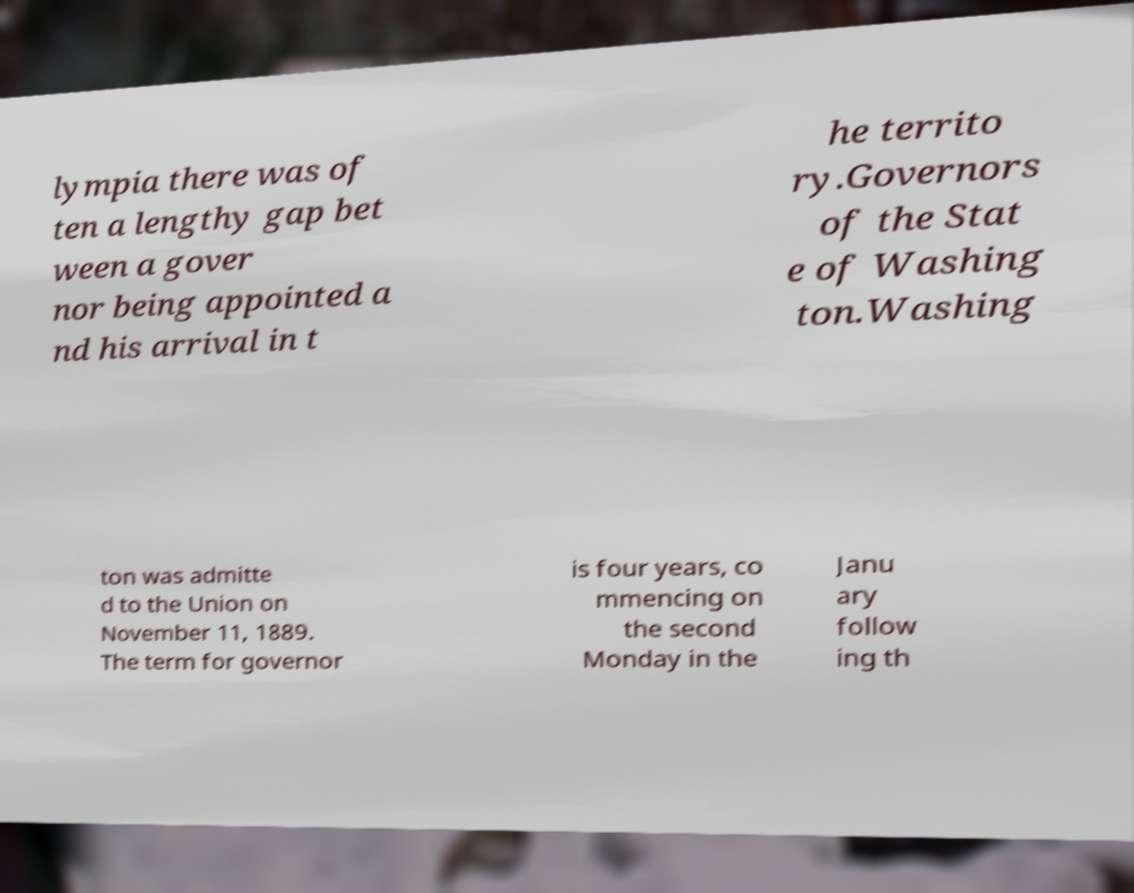Please read and relay the text visible in this image. What does it say? lympia there was of ten a lengthy gap bet ween a gover nor being appointed a nd his arrival in t he territo ry.Governors of the Stat e of Washing ton.Washing ton was admitte d to the Union on November 11, 1889. The term for governor is four years, co mmencing on the second Monday in the Janu ary follow ing th 